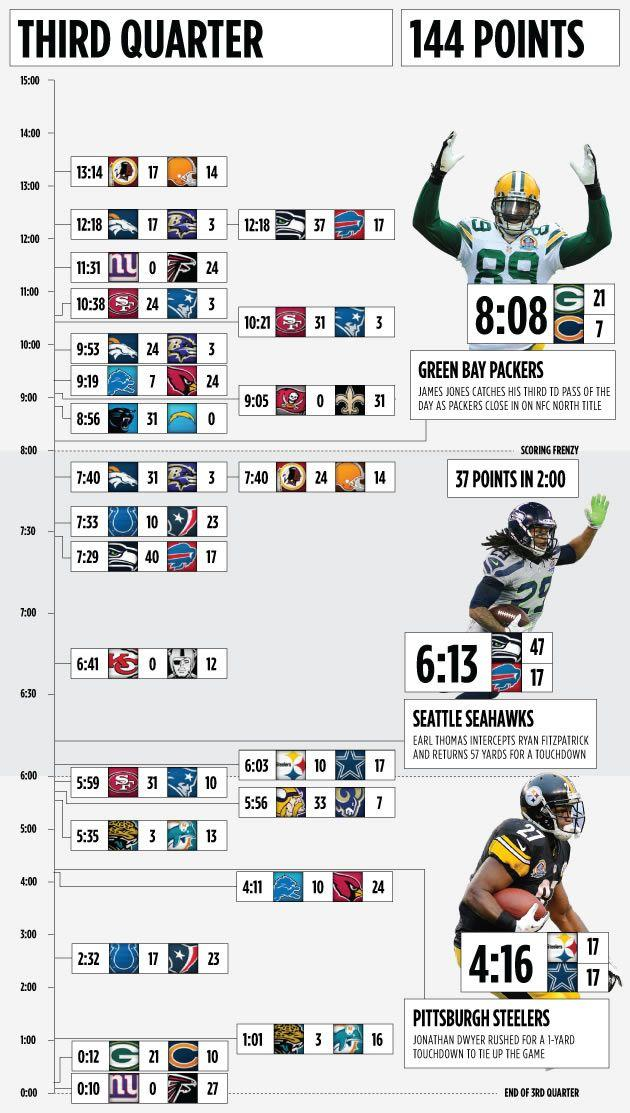Outline some significant characteristics in this image. The player wearing jersey number 29 is Earl Thomas. At 8:08, the Chicago Bears or the New York Giants scored 21 points, but it was the Green Bay Packers who scored. At 12:18, the score was 17, and both the Denver Broncos and Buffalo Bills had scored. Jonathan Dwyer is the player who wears jersey number 27. 